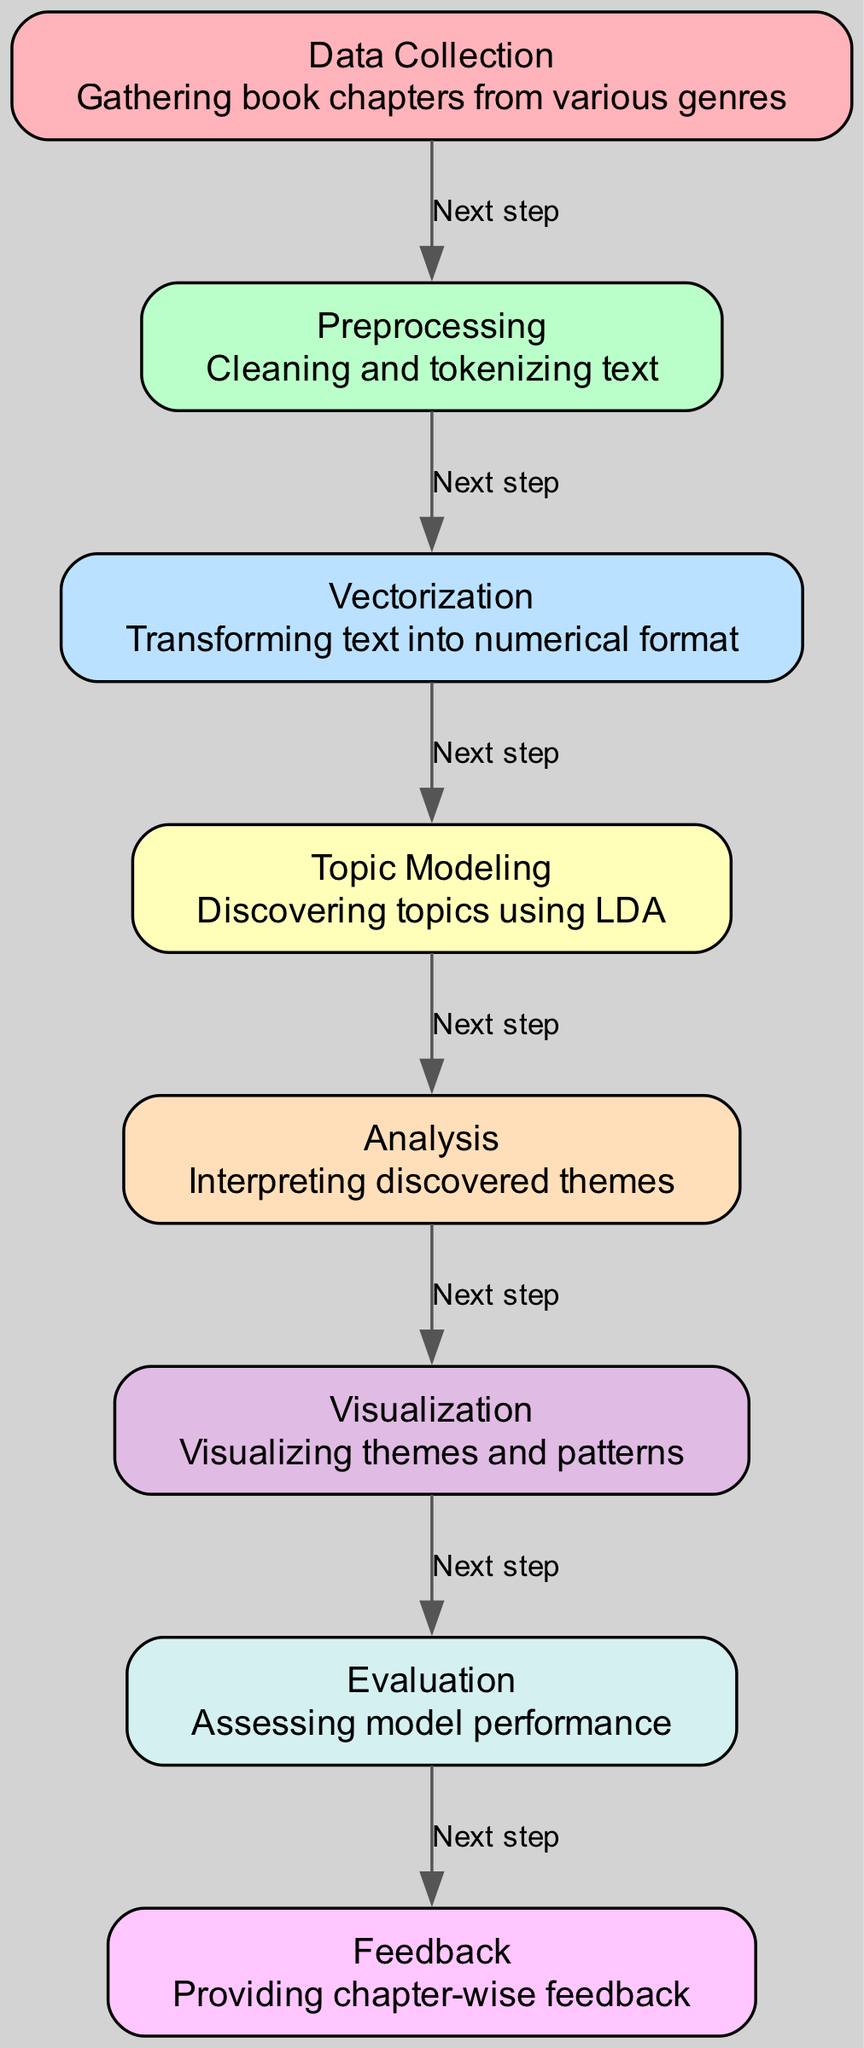What is the first step of the diagram? The first step in the diagram is "Data Collection". This is indicated by the first node listed in the diagram.
Answer: Data Collection How many nodes are there in total? The diagram contains a total of eight nodes, each representing a specific process in the topic modeling workflow.
Answer: Eight What is the relationship between "Preprocessing" and "Vectorization"? The edge between "Preprocessing" and "Vectorization" indicates that "Preprocessing" is the next step leading into "Vectorization". This shows a sequential flow from cleaning and tokenizing to transforming text.
Answer: Next step What describes the "Topic Modeling" node? The "Topic Modeling" node describes the process of discovering topics using LDA. This is the description associated with that specific node in the diagram.
Answer: Discovering topics using LDA What follows after "Visualization"? After "Visualization", the next step is "Evaluation", as shown by the directed edge leading from "Visualization" to "Evaluation".
Answer: Evaluation How many edges are present in the diagram? The diagram contains a total of seven edges that connect the various nodes, illustrating the flow from one process to another.
Answer: Seven What is the last node that receives feedback? The last node that receives feedback is "Feedback", which is the final step in the process as indicated by the flow from the previous node "Evaluation".
Answer: Feedback What is the purpose of the "Analysis" node? The "Analysis" node's purpose is to interpret the discovered themes, indicating that this step occurs after the topics have been modeled.
Answer: Interpreting discovered themes 